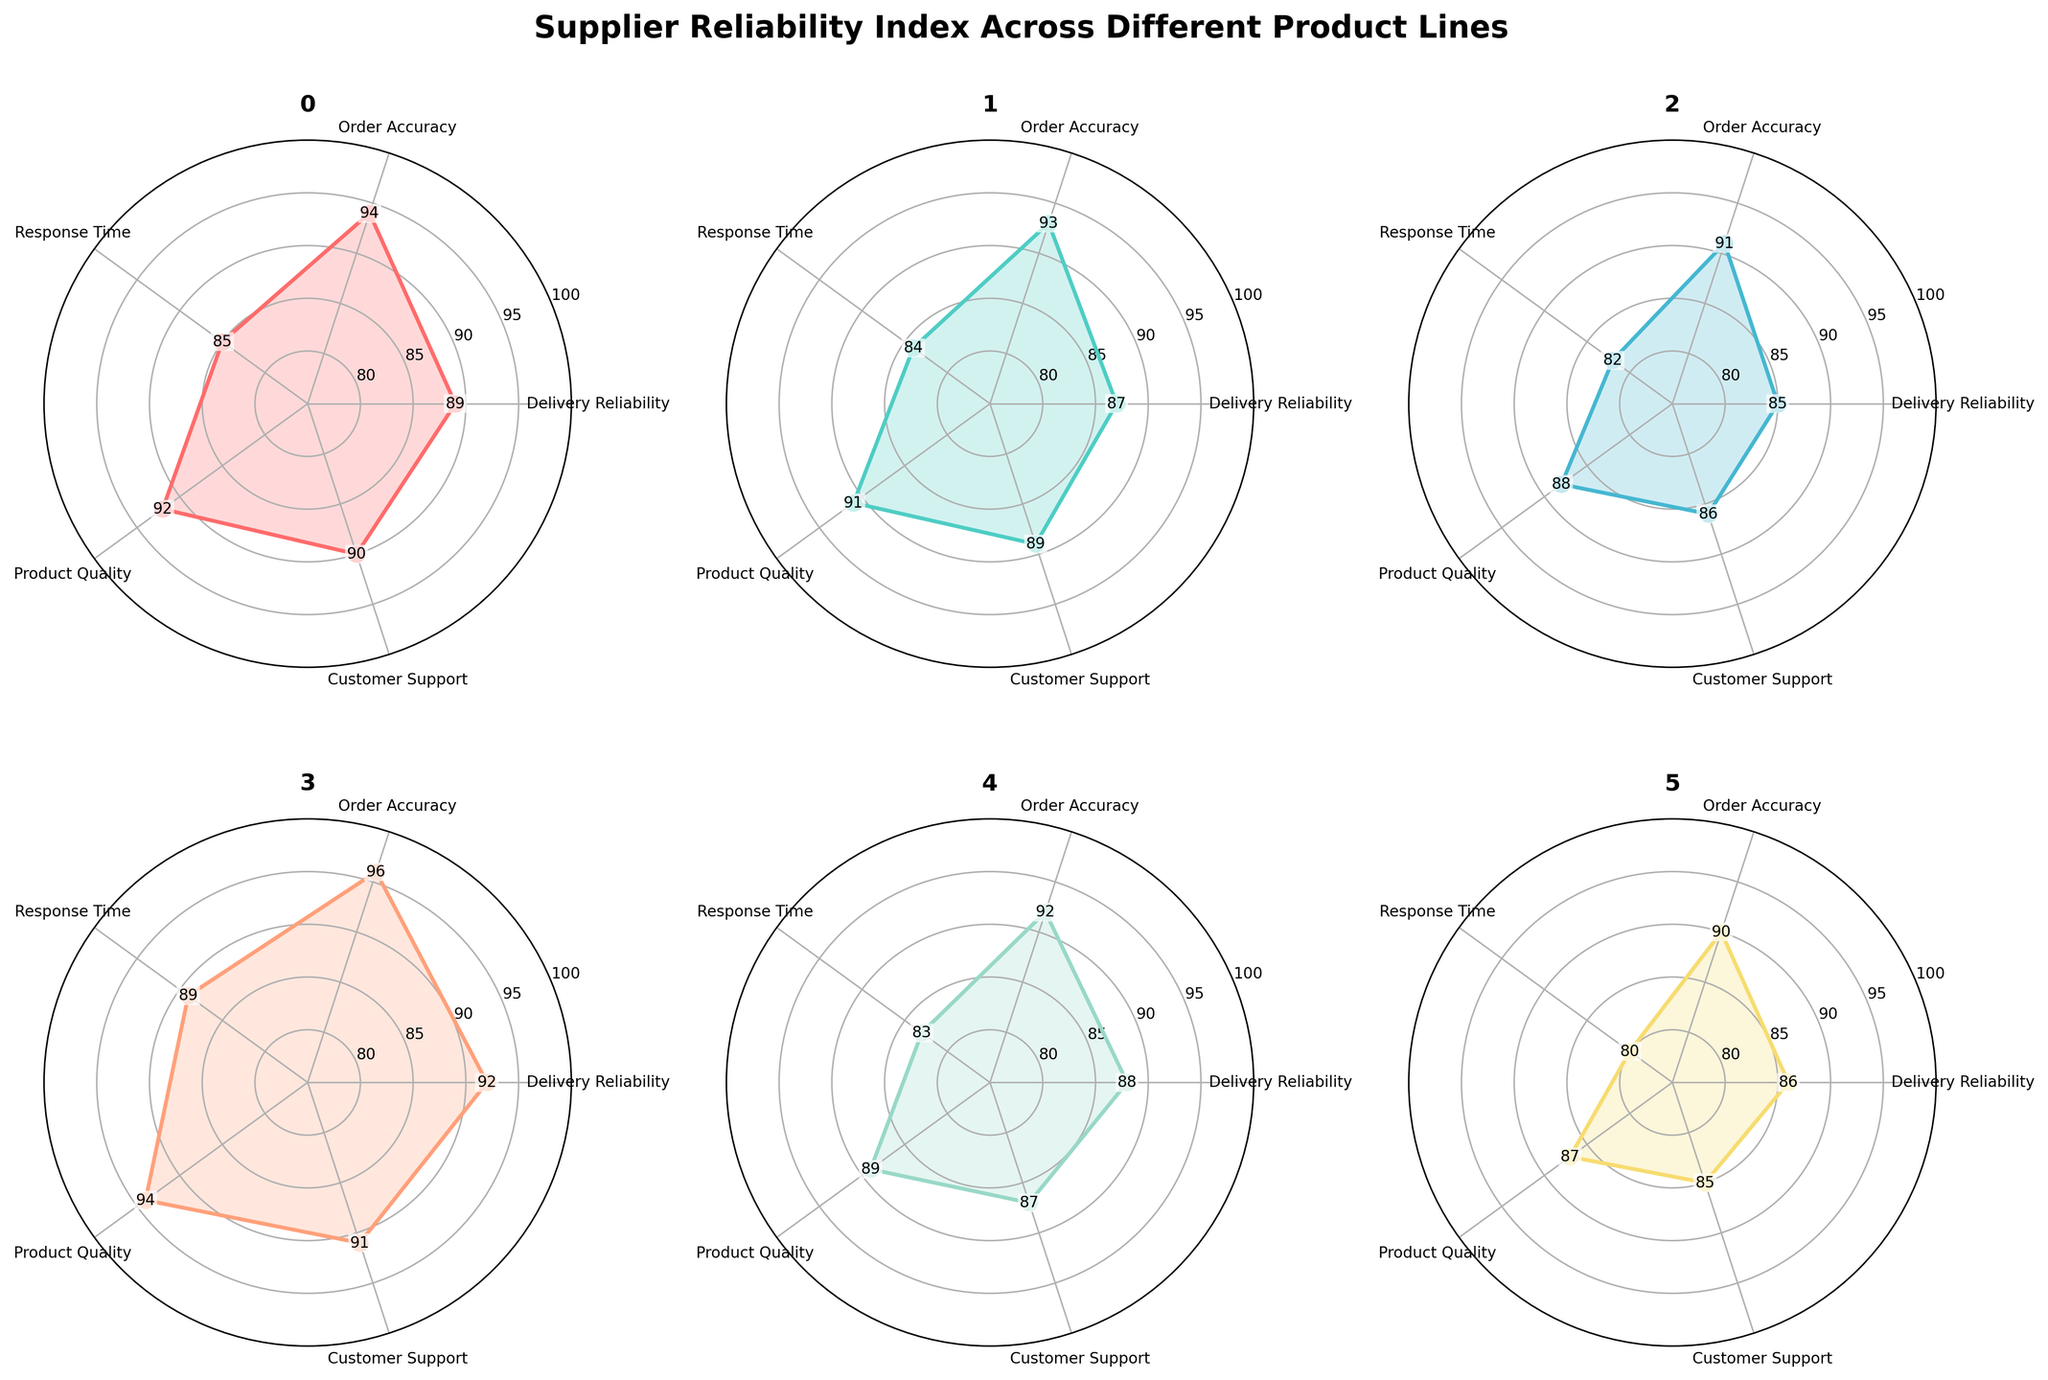Which product line has the highest "Delivery Reliability"? The product line with the highest value in the "Delivery Reliability" category would be at the tallest point on the "Delivery Reliability" axis. By checking the plot, we see that "Electronics" has the highest value.
Answer: Electronics Which product line has the lowest "Response Time"? The product line with the lowest value in the "Response Time" category would be at the lowest point on the "Response Time" axis. By looking at the subplot, "Timber" has the lowest value of 80.
Answer: Timber What's the average value of "Product Quality" across all product lines? The values for "Product Quality" are: 92 (Metals), 91 (Plastics), 88 (Chemicals), 94 (Electronics), 89 (Textiles), 87 (Timber). Sum these values to get 541, and then divide by the number of product lines, which is 6, to get the average.
Answer: 90.17 Which product line has the smallest range of values across all categories? The range for each product line is calculated by subtracting the smallest value from the largest value in that line. "Metals": 94-85=9, "Plastics": 93-84=9, "Chemicals": 91-82=9, "Electronics": 96-89=7, "Textiles": 92-83=9, "Timber": 90-80=10. "Electronics" has the smallest range.
Answer: Electronics How does "Customer Support" compare between "Plastics" and "Textiles"? The "Customer Support" values for "Plastics" and "Textiles" are 89 and 87, respectively. By comparison, "Plastics" has a higher "Customer Support" score than "Textiles".
Answer: Plastics has higher Which product line has the most consistent reliability across all categories? Consistency can be indicated by how close the values are to each other within each product line. By examining the subplots, we note that "Electronics" has values between 89 and 96, showing the smallest deviations, indicating high consistency.
Answer: Electronics 